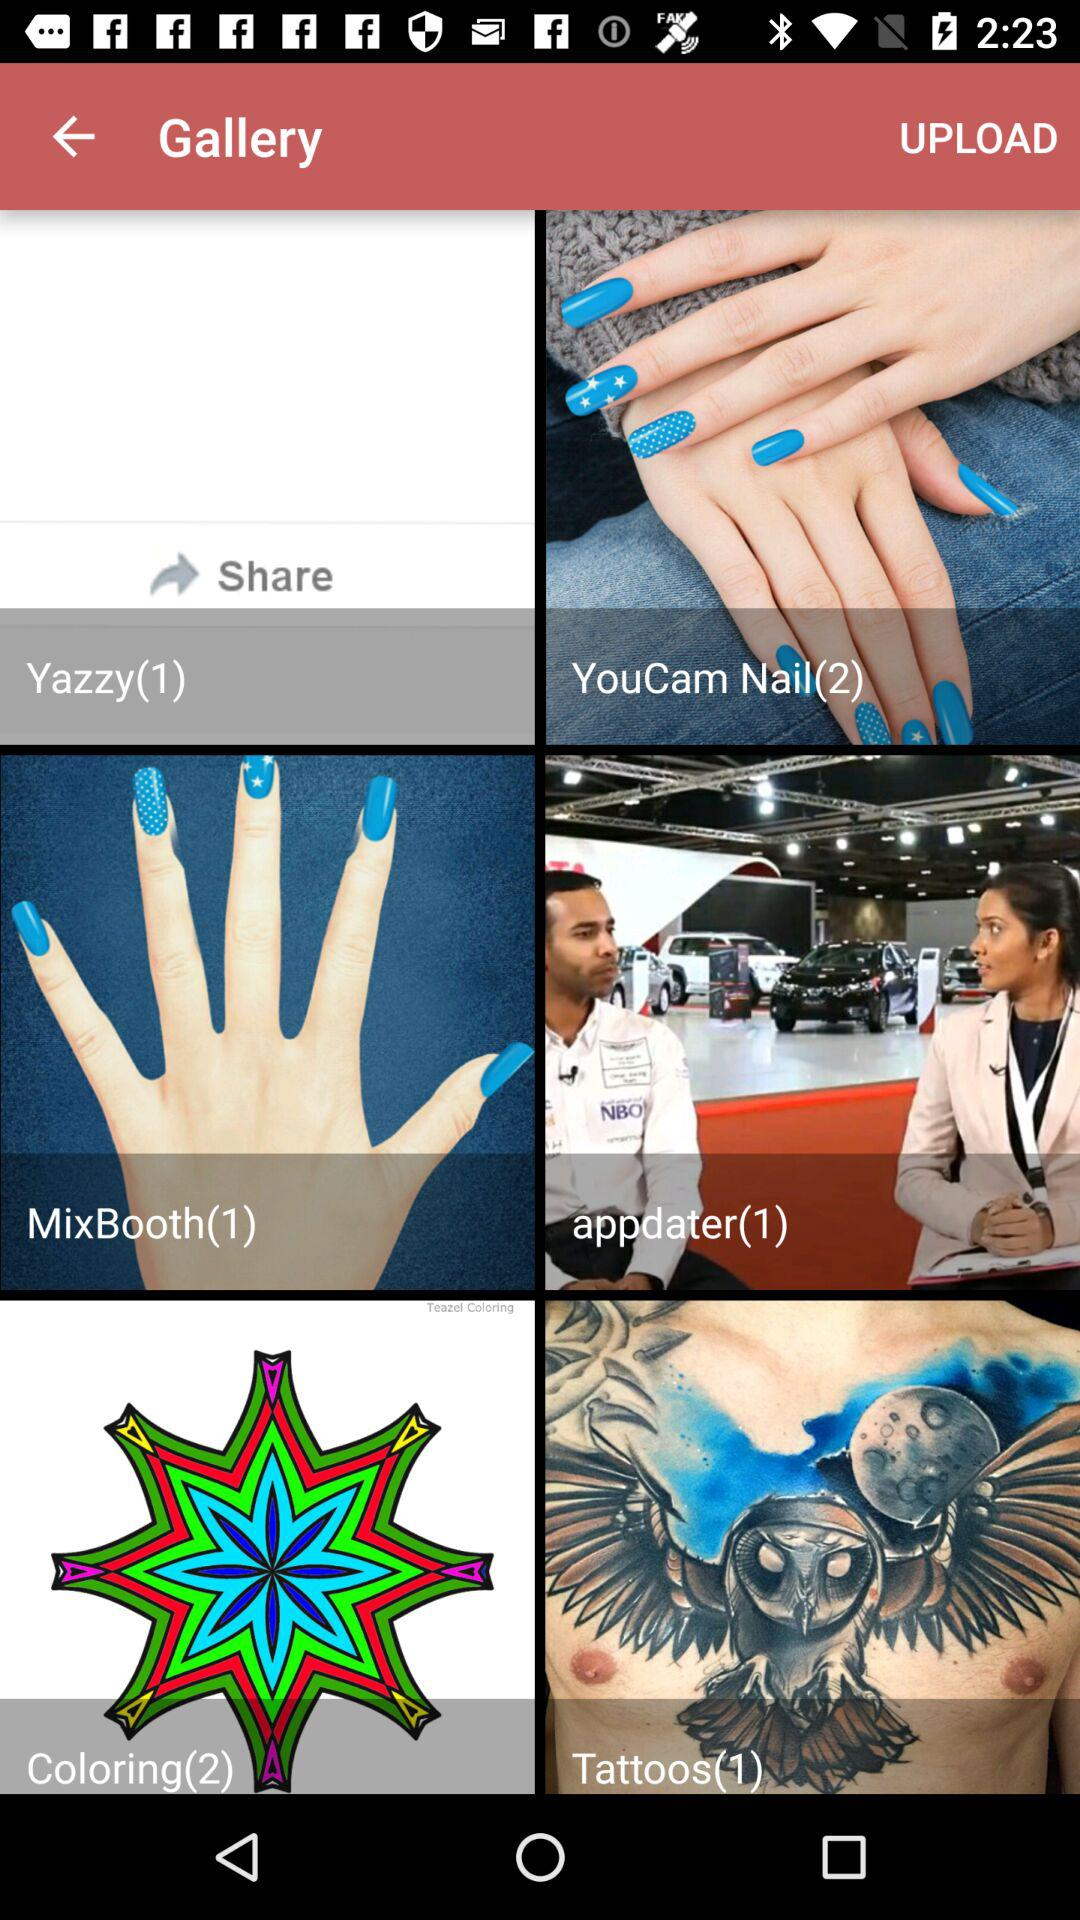Which images have been uploaded?
When the provided information is insufficient, respond with <no answer>. <no answer> 